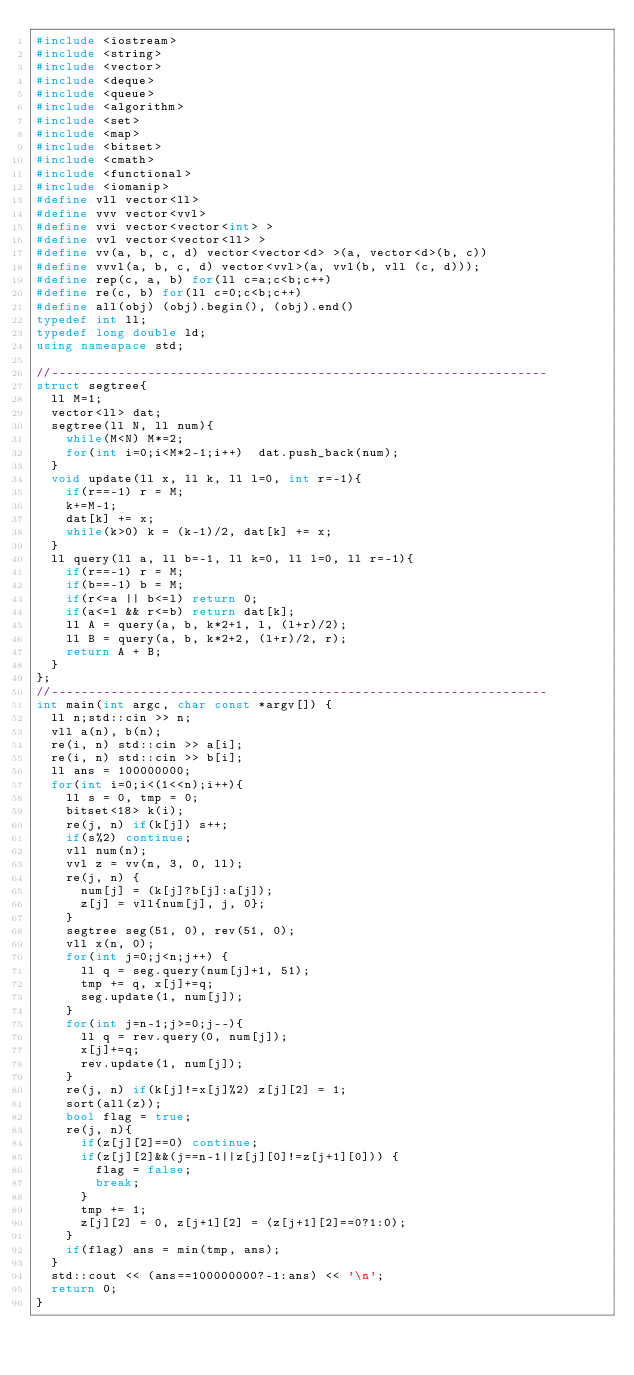<code> <loc_0><loc_0><loc_500><loc_500><_C++_>#include <iostream>
#include <string>
#include <vector>
#include <deque>
#include <queue>
#include <algorithm>
#include <set>
#include <map>
#include <bitset>
#include <cmath>
#include <functional>
#include <iomanip>
#define vll vector<ll>
#define vvv vector<vvl>
#define vvi vector<vector<int> >
#define vvl vector<vector<ll> >
#define vv(a, b, c, d) vector<vector<d> >(a, vector<d>(b, c))
#define vvvl(a, b, c, d) vector<vvl>(a, vvl(b, vll (c, d)));
#define rep(c, a, b) for(ll c=a;c<b;c++)
#define re(c, b) for(ll c=0;c<b;c++)
#define all(obj) (obj).begin(), (obj).end()
typedef int ll;
typedef long double ld;
using namespace std;

//-------------------------------------------------------------------
struct segtree{
  ll M=1;
  vector<ll> dat;
  segtree(ll N, ll num){
    while(M<N) M*=2;
    for(int i=0;i<M*2-1;i++)  dat.push_back(num);
  }
  void update(ll x, ll k, ll l=0, int r=-1){
    if(r==-1) r = M;
    k+=M-1;
    dat[k] += x;
    while(k>0) k = (k-1)/2, dat[k] += x;
  }
  ll query(ll a, ll b=-1, ll k=0, ll l=0, ll r=-1){
    if(r==-1) r = M;
    if(b==-1) b = M;
    if(r<=a || b<=l) return 0;
    if(a<=l && r<=b) return dat[k];
    ll A = query(a, b, k*2+1, l, (l+r)/2);
    ll B = query(a, b, k*2+2, (l+r)/2, r);
    return A + B;
  }
};
//-------------------------------------------------------------------
int main(int argc, char const *argv[]) {
  ll n;std::cin >> n;
  vll a(n), b(n);
  re(i, n) std::cin >> a[i];
  re(i, n) std::cin >> b[i];
  ll ans = 100000000;
  for(int i=0;i<(1<<n);i++){
    ll s = 0, tmp = 0;
    bitset<18> k(i);
    re(j, n) if(k[j]) s++;
    if(s%2) continue;
    vll num(n);
    vvl z = vv(n, 3, 0, ll);
    re(j, n) {
      num[j] = (k[j]?b[j]:a[j]);
      z[j] = vll{num[j], j, 0};
    }
    segtree seg(51, 0), rev(51, 0);
    vll x(n, 0);
    for(int j=0;j<n;j++) {
      ll q = seg.query(num[j]+1, 51);
      tmp += q, x[j]+=q;
      seg.update(1, num[j]);
    }
    for(int j=n-1;j>=0;j--){
      ll q = rev.query(0, num[j]);
      x[j]+=q;
      rev.update(1, num[j]);
    }
    re(j, n) if(k[j]!=x[j]%2) z[j][2] = 1;
    sort(all(z));
    bool flag = true;
    re(j, n){
      if(z[j][2]==0) continue;
      if(z[j][2]&&(j==n-1||z[j][0]!=z[j+1][0])) {
        flag = false;
        break;
      }
      tmp += 1;
      z[j][2] = 0, z[j+1][2] = (z[j+1][2]==0?1:0);
    }
    if(flag) ans = min(tmp, ans);
  }
  std::cout << (ans==100000000?-1:ans) << '\n';
  return 0;
}
</code> 